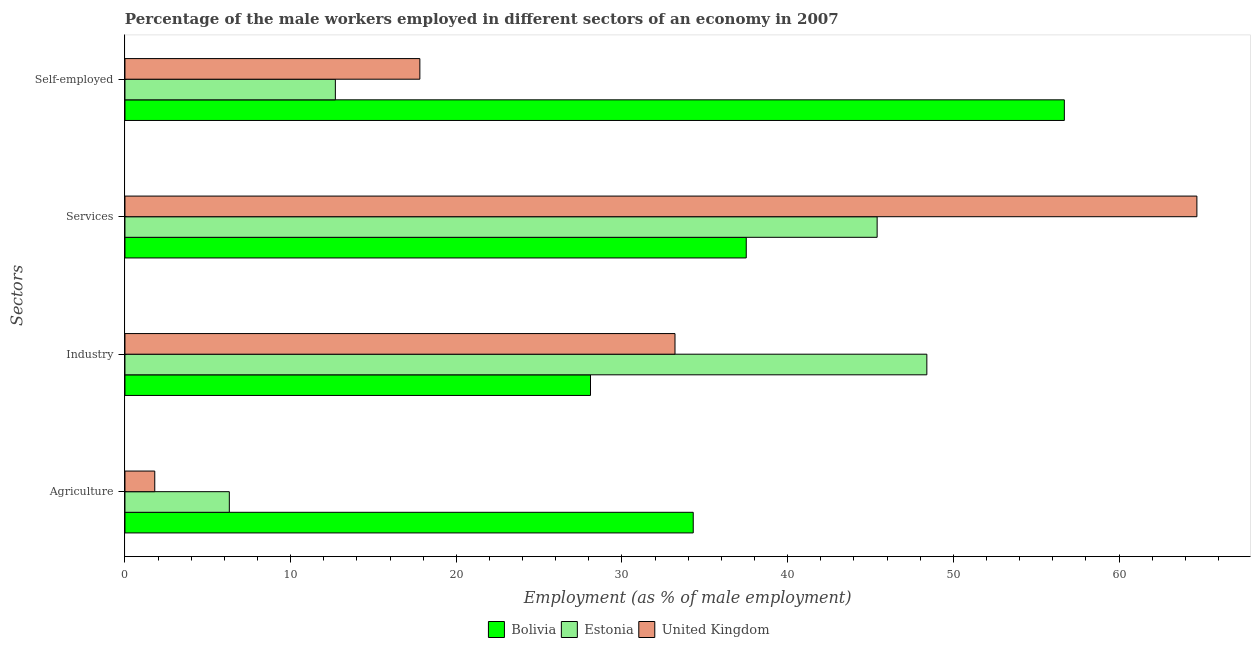Are the number of bars on each tick of the Y-axis equal?
Make the answer very short. Yes. What is the label of the 1st group of bars from the top?
Offer a very short reply. Self-employed. What is the percentage of male workers in industry in Estonia?
Offer a terse response. 48.4. Across all countries, what is the maximum percentage of self employed male workers?
Ensure brevity in your answer.  56.7. Across all countries, what is the minimum percentage of male workers in agriculture?
Offer a very short reply. 1.8. In which country was the percentage of male workers in services maximum?
Your answer should be compact. United Kingdom. What is the total percentage of male workers in agriculture in the graph?
Offer a very short reply. 42.4. What is the difference between the percentage of male workers in industry in Estonia and that in United Kingdom?
Offer a terse response. 15.2. What is the difference between the percentage of male workers in industry in Estonia and the percentage of male workers in agriculture in United Kingdom?
Keep it short and to the point. 46.6. What is the average percentage of male workers in services per country?
Your response must be concise. 49.2. What is the difference between the percentage of male workers in agriculture and percentage of male workers in services in United Kingdom?
Keep it short and to the point. -62.9. What is the ratio of the percentage of male workers in industry in Bolivia to that in Estonia?
Provide a short and direct response. 0.58. Is the percentage of male workers in industry in Bolivia less than that in Estonia?
Offer a terse response. Yes. Is the difference between the percentage of male workers in agriculture in Estonia and United Kingdom greater than the difference between the percentage of male workers in industry in Estonia and United Kingdom?
Give a very brief answer. No. What is the difference between the highest and the second highest percentage of male workers in agriculture?
Your answer should be very brief. 28. What is the difference between the highest and the lowest percentage of male workers in services?
Keep it short and to the point. 27.2. Is the sum of the percentage of male workers in agriculture in Bolivia and Estonia greater than the maximum percentage of male workers in services across all countries?
Provide a succinct answer. No. What does the 3rd bar from the top in Services represents?
Offer a terse response. Bolivia. What does the 2nd bar from the bottom in Self-employed represents?
Your response must be concise. Estonia. Is it the case that in every country, the sum of the percentage of male workers in agriculture and percentage of male workers in industry is greater than the percentage of male workers in services?
Offer a terse response. No. How many bars are there?
Ensure brevity in your answer.  12. Are all the bars in the graph horizontal?
Provide a short and direct response. Yes. What is the difference between two consecutive major ticks on the X-axis?
Make the answer very short. 10. Does the graph contain any zero values?
Give a very brief answer. No. Where does the legend appear in the graph?
Provide a short and direct response. Bottom center. What is the title of the graph?
Give a very brief answer. Percentage of the male workers employed in different sectors of an economy in 2007. What is the label or title of the X-axis?
Your response must be concise. Employment (as % of male employment). What is the label or title of the Y-axis?
Keep it short and to the point. Sectors. What is the Employment (as % of male employment) of Bolivia in Agriculture?
Give a very brief answer. 34.3. What is the Employment (as % of male employment) of Estonia in Agriculture?
Your answer should be very brief. 6.3. What is the Employment (as % of male employment) of United Kingdom in Agriculture?
Offer a very short reply. 1.8. What is the Employment (as % of male employment) of Bolivia in Industry?
Ensure brevity in your answer.  28.1. What is the Employment (as % of male employment) in Estonia in Industry?
Your answer should be compact. 48.4. What is the Employment (as % of male employment) in United Kingdom in Industry?
Your answer should be compact. 33.2. What is the Employment (as % of male employment) of Bolivia in Services?
Your response must be concise. 37.5. What is the Employment (as % of male employment) of Estonia in Services?
Provide a succinct answer. 45.4. What is the Employment (as % of male employment) of United Kingdom in Services?
Your answer should be compact. 64.7. What is the Employment (as % of male employment) of Bolivia in Self-employed?
Make the answer very short. 56.7. What is the Employment (as % of male employment) of Estonia in Self-employed?
Keep it short and to the point. 12.7. What is the Employment (as % of male employment) of United Kingdom in Self-employed?
Your answer should be compact. 17.8. Across all Sectors, what is the maximum Employment (as % of male employment) in Bolivia?
Your answer should be very brief. 56.7. Across all Sectors, what is the maximum Employment (as % of male employment) of Estonia?
Provide a succinct answer. 48.4. Across all Sectors, what is the maximum Employment (as % of male employment) of United Kingdom?
Keep it short and to the point. 64.7. Across all Sectors, what is the minimum Employment (as % of male employment) of Bolivia?
Provide a short and direct response. 28.1. Across all Sectors, what is the minimum Employment (as % of male employment) of Estonia?
Give a very brief answer. 6.3. Across all Sectors, what is the minimum Employment (as % of male employment) in United Kingdom?
Offer a terse response. 1.8. What is the total Employment (as % of male employment) of Bolivia in the graph?
Keep it short and to the point. 156.6. What is the total Employment (as % of male employment) of Estonia in the graph?
Give a very brief answer. 112.8. What is the total Employment (as % of male employment) of United Kingdom in the graph?
Give a very brief answer. 117.5. What is the difference between the Employment (as % of male employment) in Bolivia in Agriculture and that in Industry?
Give a very brief answer. 6.2. What is the difference between the Employment (as % of male employment) of Estonia in Agriculture and that in Industry?
Your response must be concise. -42.1. What is the difference between the Employment (as % of male employment) in United Kingdom in Agriculture and that in Industry?
Ensure brevity in your answer.  -31.4. What is the difference between the Employment (as % of male employment) in Estonia in Agriculture and that in Services?
Give a very brief answer. -39.1. What is the difference between the Employment (as % of male employment) in United Kingdom in Agriculture and that in Services?
Give a very brief answer. -62.9. What is the difference between the Employment (as % of male employment) in Bolivia in Agriculture and that in Self-employed?
Make the answer very short. -22.4. What is the difference between the Employment (as % of male employment) in Estonia in Agriculture and that in Self-employed?
Provide a succinct answer. -6.4. What is the difference between the Employment (as % of male employment) of United Kingdom in Agriculture and that in Self-employed?
Keep it short and to the point. -16. What is the difference between the Employment (as % of male employment) of Estonia in Industry and that in Services?
Offer a very short reply. 3. What is the difference between the Employment (as % of male employment) of United Kingdom in Industry and that in Services?
Keep it short and to the point. -31.5. What is the difference between the Employment (as % of male employment) of Bolivia in Industry and that in Self-employed?
Your response must be concise. -28.6. What is the difference between the Employment (as % of male employment) in Estonia in Industry and that in Self-employed?
Give a very brief answer. 35.7. What is the difference between the Employment (as % of male employment) of Bolivia in Services and that in Self-employed?
Your answer should be very brief. -19.2. What is the difference between the Employment (as % of male employment) of Estonia in Services and that in Self-employed?
Provide a short and direct response. 32.7. What is the difference between the Employment (as % of male employment) in United Kingdom in Services and that in Self-employed?
Keep it short and to the point. 46.9. What is the difference between the Employment (as % of male employment) of Bolivia in Agriculture and the Employment (as % of male employment) of Estonia in Industry?
Your answer should be very brief. -14.1. What is the difference between the Employment (as % of male employment) of Estonia in Agriculture and the Employment (as % of male employment) of United Kingdom in Industry?
Keep it short and to the point. -26.9. What is the difference between the Employment (as % of male employment) in Bolivia in Agriculture and the Employment (as % of male employment) in Estonia in Services?
Offer a very short reply. -11.1. What is the difference between the Employment (as % of male employment) in Bolivia in Agriculture and the Employment (as % of male employment) in United Kingdom in Services?
Provide a succinct answer. -30.4. What is the difference between the Employment (as % of male employment) in Estonia in Agriculture and the Employment (as % of male employment) in United Kingdom in Services?
Provide a succinct answer. -58.4. What is the difference between the Employment (as % of male employment) in Bolivia in Agriculture and the Employment (as % of male employment) in Estonia in Self-employed?
Your answer should be compact. 21.6. What is the difference between the Employment (as % of male employment) in Estonia in Agriculture and the Employment (as % of male employment) in United Kingdom in Self-employed?
Make the answer very short. -11.5. What is the difference between the Employment (as % of male employment) of Bolivia in Industry and the Employment (as % of male employment) of Estonia in Services?
Make the answer very short. -17.3. What is the difference between the Employment (as % of male employment) in Bolivia in Industry and the Employment (as % of male employment) in United Kingdom in Services?
Offer a very short reply. -36.6. What is the difference between the Employment (as % of male employment) in Estonia in Industry and the Employment (as % of male employment) in United Kingdom in Services?
Offer a very short reply. -16.3. What is the difference between the Employment (as % of male employment) of Bolivia in Industry and the Employment (as % of male employment) of United Kingdom in Self-employed?
Your answer should be compact. 10.3. What is the difference between the Employment (as % of male employment) in Estonia in Industry and the Employment (as % of male employment) in United Kingdom in Self-employed?
Provide a succinct answer. 30.6. What is the difference between the Employment (as % of male employment) of Bolivia in Services and the Employment (as % of male employment) of Estonia in Self-employed?
Offer a very short reply. 24.8. What is the difference between the Employment (as % of male employment) in Estonia in Services and the Employment (as % of male employment) in United Kingdom in Self-employed?
Offer a very short reply. 27.6. What is the average Employment (as % of male employment) of Bolivia per Sectors?
Your answer should be very brief. 39.15. What is the average Employment (as % of male employment) in Estonia per Sectors?
Your answer should be compact. 28.2. What is the average Employment (as % of male employment) of United Kingdom per Sectors?
Make the answer very short. 29.38. What is the difference between the Employment (as % of male employment) of Bolivia and Employment (as % of male employment) of United Kingdom in Agriculture?
Offer a very short reply. 32.5. What is the difference between the Employment (as % of male employment) of Estonia and Employment (as % of male employment) of United Kingdom in Agriculture?
Provide a short and direct response. 4.5. What is the difference between the Employment (as % of male employment) in Bolivia and Employment (as % of male employment) in Estonia in Industry?
Give a very brief answer. -20.3. What is the difference between the Employment (as % of male employment) of Bolivia and Employment (as % of male employment) of United Kingdom in Industry?
Offer a very short reply. -5.1. What is the difference between the Employment (as % of male employment) of Estonia and Employment (as % of male employment) of United Kingdom in Industry?
Offer a terse response. 15.2. What is the difference between the Employment (as % of male employment) in Bolivia and Employment (as % of male employment) in United Kingdom in Services?
Your response must be concise. -27.2. What is the difference between the Employment (as % of male employment) of Estonia and Employment (as % of male employment) of United Kingdom in Services?
Give a very brief answer. -19.3. What is the difference between the Employment (as % of male employment) of Bolivia and Employment (as % of male employment) of Estonia in Self-employed?
Give a very brief answer. 44. What is the difference between the Employment (as % of male employment) of Bolivia and Employment (as % of male employment) of United Kingdom in Self-employed?
Provide a short and direct response. 38.9. What is the difference between the Employment (as % of male employment) of Estonia and Employment (as % of male employment) of United Kingdom in Self-employed?
Your response must be concise. -5.1. What is the ratio of the Employment (as % of male employment) of Bolivia in Agriculture to that in Industry?
Offer a terse response. 1.22. What is the ratio of the Employment (as % of male employment) in Estonia in Agriculture to that in Industry?
Your answer should be very brief. 0.13. What is the ratio of the Employment (as % of male employment) of United Kingdom in Agriculture to that in Industry?
Your answer should be very brief. 0.05. What is the ratio of the Employment (as % of male employment) in Bolivia in Agriculture to that in Services?
Offer a very short reply. 0.91. What is the ratio of the Employment (as % of male employment) of Estonia in Agriculture to that in Services?
Provide a succinct answer. 0.14. What is the ratio of the Employment (as % of male employment) of United Kingdom in Agriculture to that in Services?
Your answer should be compact. 0.03. What is the ratio of the Employment (as % of male employment) in Bolivia in Agriculture to that in Self-employed?
Your response must be concise. 0.6. What is the ratio of the Employment (as % of male employment) in Estonia in Agriculture to that in Self-employed?
Make the answer very short. 0.5. What is the ratio of the Employment (as % of male employment) of United Kingdom in Agriculture to that in Self-employed?
Give a very brief answer. 0.1. What is the ratio of the Employment (as % of male employment) of Bolivia in Industry to that in Services?
Offer a terse response. 0.75. What is the ratio of the Employment (as % of male employment) of Estonia in Industry to that in Services?
Your answer should be compact. 1.07. What is the ratio of the Employment (as % of male employment) of United Kingdom in Industry to that in Services?
Your response must be concise. 0.51. What is the ratio of the Employment (as % of male employment) in Bolivia in Industry to that in Self-employed?
Give a very brief answer. 0.5. What is the ratio of the Employment (as % of male employment) in Estonia in Industry to that in Self-employed?
Offer a terse response. 3.81. What is the ratio of the Employment (as % of male employment) of United Kingdom in Industry to that in Self-employed?
Give a very brief answer. 1.87. What is the ratio of the Employment (as % of male employment) in Bolivia in Services to that in Self-employed?
Give a very brief answer. 0.66. What is the ratio of the Employment (as % of male employment) of Estonia in Services to that in Self-employed?
Make the answer very short. 3.57. What is the ratio of the Employment (as % of male employment) in United Kingdom in Services to that in Self-employed?
Your response must be concise. 3.63. What is the difference between the highest and the second highest Employment (as % of male employment) in Bolivia?
Offer a very short reply. 19.2. What is the difference between the highest and the second highest Employment (as % of male employment) of United Kingdom?
Keep it short and to the point. 31.5. What is the difference between the highest and the lowest Employment (as % of male employment) in Bolivia?
Your answer should be compact. 28.6. What is the difference between the highest and the lowest Employment (as % of male employment) in Estonia?
Provide a short and direct response. 42.1. What is the difference between the highest and the lowest Employment (as % of male employment) in United Kingdom?
Your response must be concise. 62.9. 